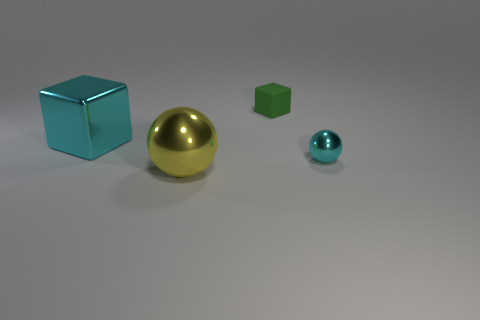How many big shiny spheres are there?
Make the answer very short. 1. There is a big cyan thing that is the same material as the cyan sphere; what shape is it?
Your response must be concise. Cube. There is a block in front of the matte block; is it the same color as the metal object that is on the right side of the yellow metal object?
Provide a short and direct response. Yes. Are there the same number of cyan shiny things in front of the big yellow thing and purple cylinders?
Your answer should be very brief. Yes. How many cyan shiny objects are left of the tiny green thing?
Provide a succinct answer. 1. What is the size of the yellow metal sphere?
Your response must be concise. Large. The large ball that is made of the same material as the tiny sphere is what color?
Offer a very short reply. Yellow. What number of shiny cubes have the same size as the yellow metallic ball?
Provide a short and direct response. 1. Are the big thing on the right side of the large cyan object and the tiny cyan object made of the same material?
Keep it short and to the point. Yes. Are there fewer big metal things to the left of the yellow metal thing than brown matte spheres?
Give a very brief answer. No. 